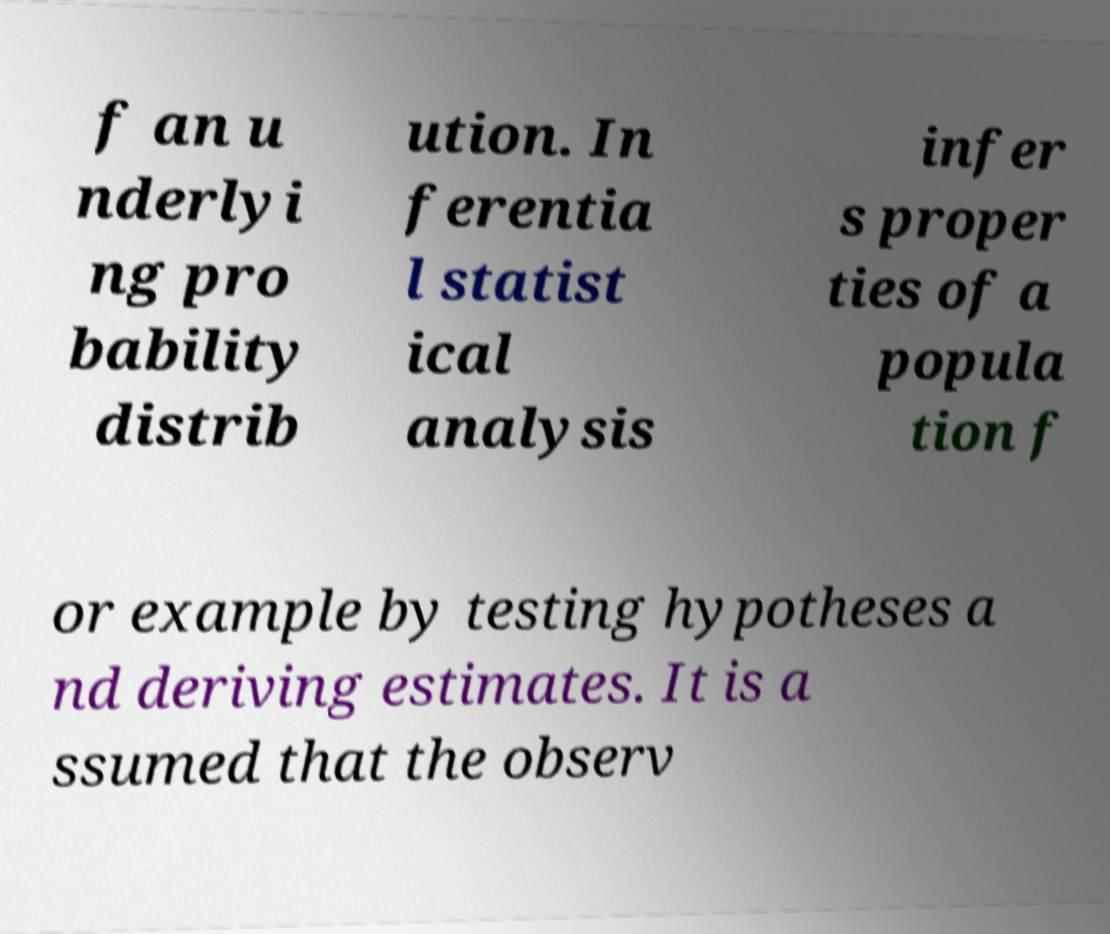Can you accurately transcribe the text from the provided image for me? f an u nderlyi ng pro bability distrib ution. In ferentia l statist ical analysis infer s proper ties of a popula tion f or example by testing hypotheses a nd deriving estimates. It is a ssumed that the observ 